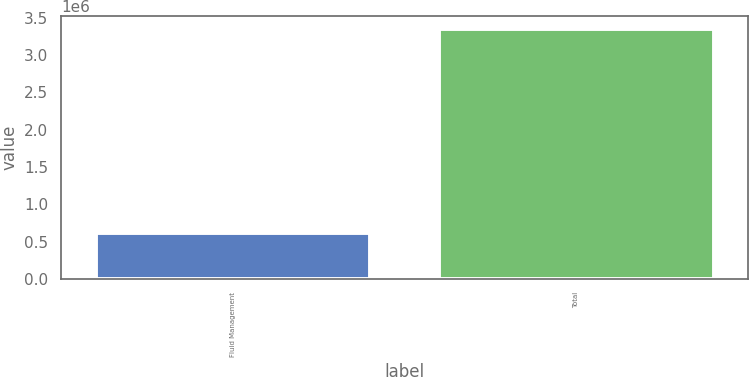Convert chart to OTSL. <chart><loc_0><loc_0><loc_500><loc_500><bar_chart><fcel>Fluid Management<fcel>Total<nl><fcel>617932<fcel>3.35022e+06<nl></chart> 